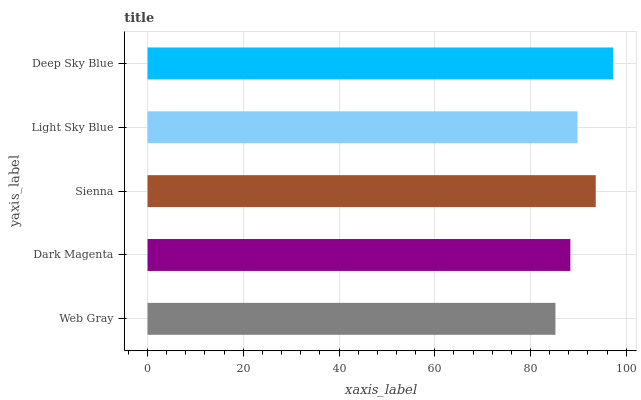Is Web Gray the minimum?
Answer yes or no. Yes. Is Deep Sky Blue the maximum?
Answer yes or no. Yes. Is Dark Magenta the minimum?
Answer yes or no. No. Is Dark Magenta the maximum?
Answer yes or no. No. Is Dark Magenta greater than Web Gray?
Answer yes or no. Yes. Is Web Gray less than Dark Magenta?
Answer yes or no. Yes. Is Web Gray greater than Dark Magenta?
Answer yes or no. No. Is Dark Magenta less than Web Gray?
Answer yes or no. No. Is Light Sky Blue the high median?
Answer yes or no. Yes. Is Light Sky Blue the low median?
Answer yes or no. Yes. Is Sienna the high median?
Answer yes or no. No. Is Sienna the low median?
Answer yes or no. No. 